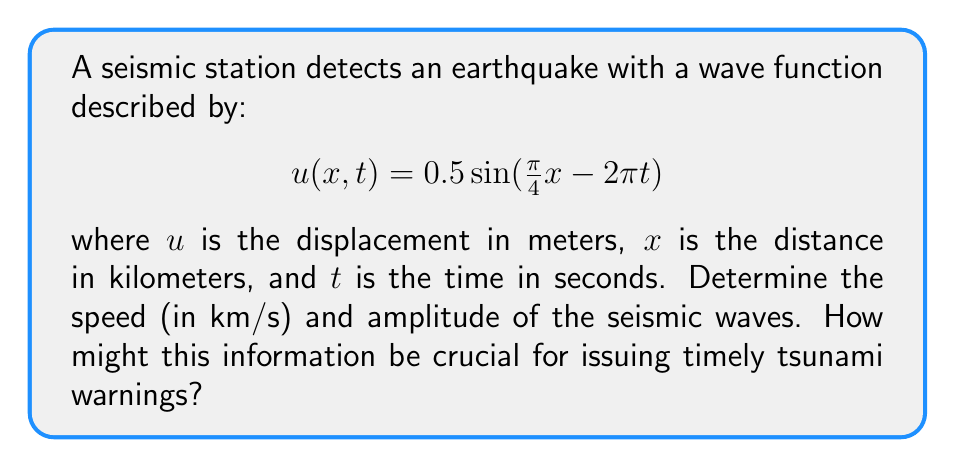Could you help me with this problem? To solve this problem, we'll follow these steps:

1) The general form of a wave equation is:
   $$u(x,t) = A \sin(kx - \omega t)$$
   where $A$ is the amplitude, $k$ is the wave number, and $\omega$ is the angular frequency.

2) Comparing our equation to the general form:
   $$u(x,t) = 0.5 \sin(\frac{\pi}{4}x - 2\pi t)$$
   We can identify:
   $A = 0.5$ meters
   $k = \frac{\pi}{4}$ km^(-1)
   $\omega = 2\pi$ s^(-1)

3) The amplitude is directly given by $A = 0.5$ meters.

4) To find the speed, we use the relation:
   $$v = \frac{\omega}{k}$$

5) Substituting the values:
   $$v = \frac{2\pi}{\frac{\pi}{4}} = 8$$ km/s

6) This information is crucial for tsunami warnings because:
   a) The amplitude indicates the strength of the earthquake, which correlates with tsunami potential.
   b) The speed allows us to calculate arrival times at different coastal locations, enabling timely warnings.
Answer: Speed: 8 km/s, Amplitude: 0.5 m 